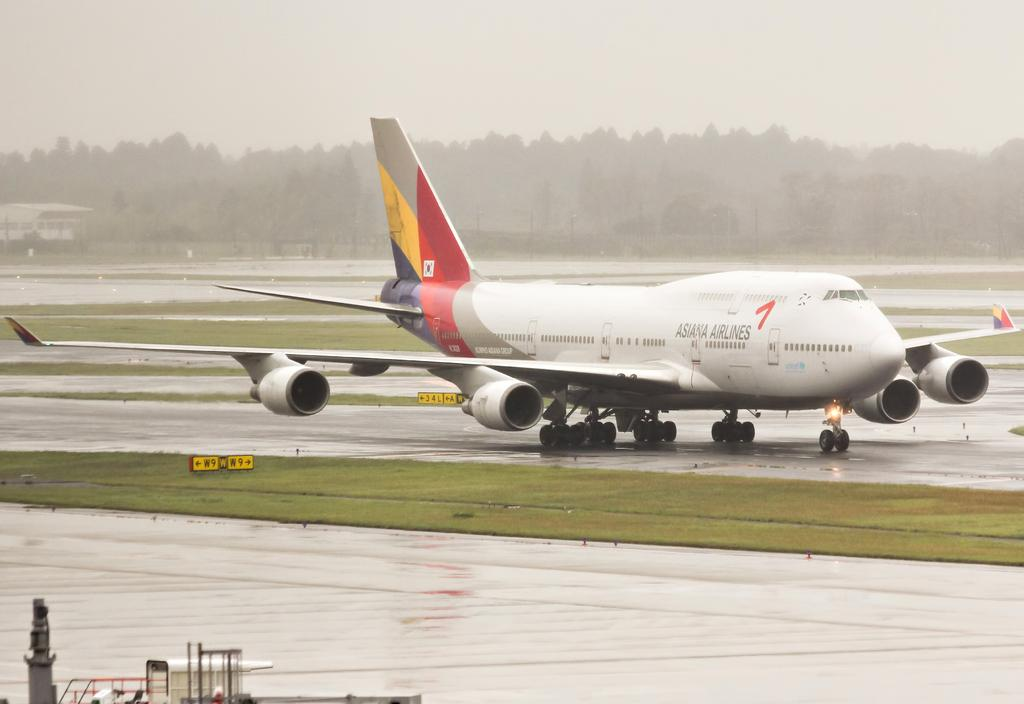<image>
Describe the image concisely. A big plane from Asiana Airlines sits on a wet runway. 